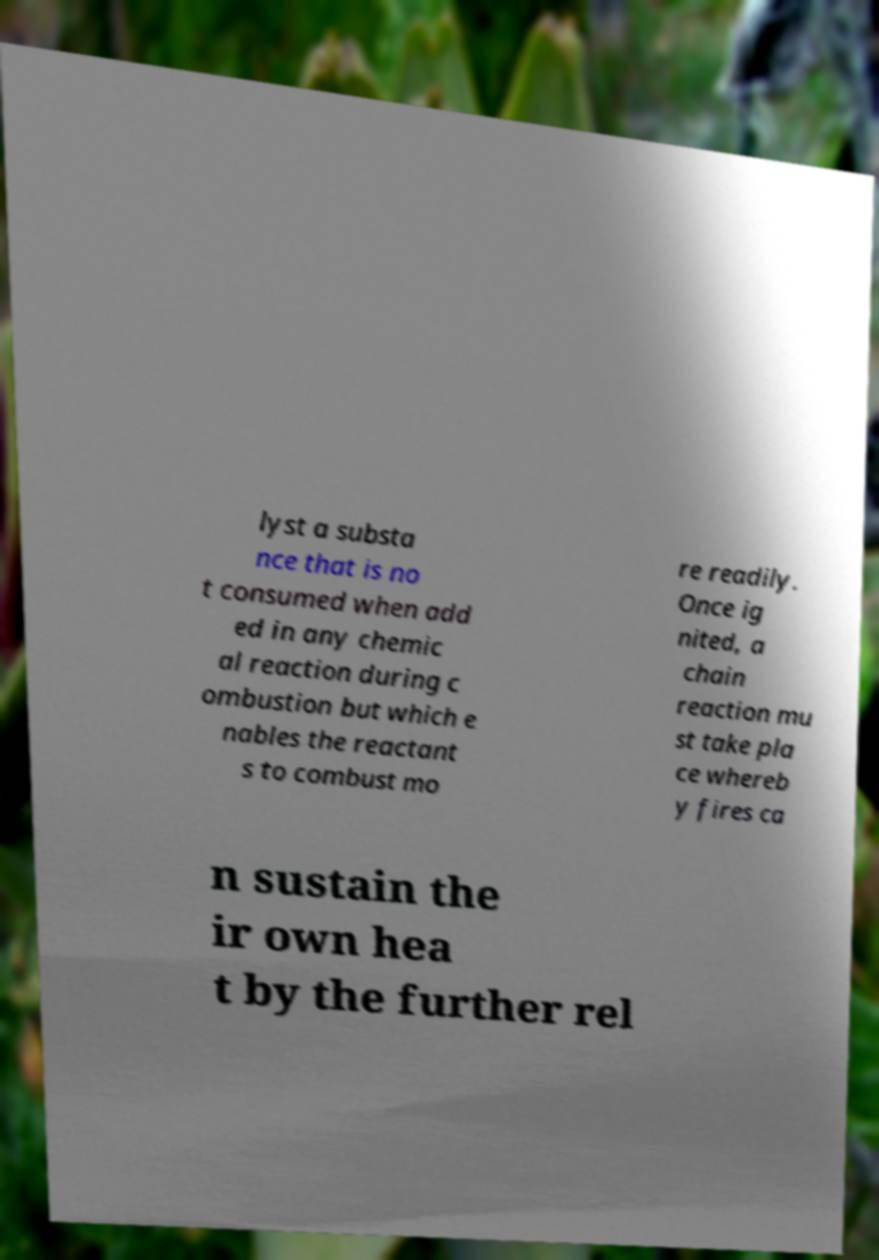For documentation purposes, I need the text within this image transcribed. Could you provide that? lyst a substa nce that is no t consumed when add ed in any chemic al reaction during c ombustion but which e nables the reactant s to combust mo re readily. Once ig nited, a chain reaction mu st take pla ce whereb y fires ca n sustain the ir own hea t by the further rel 